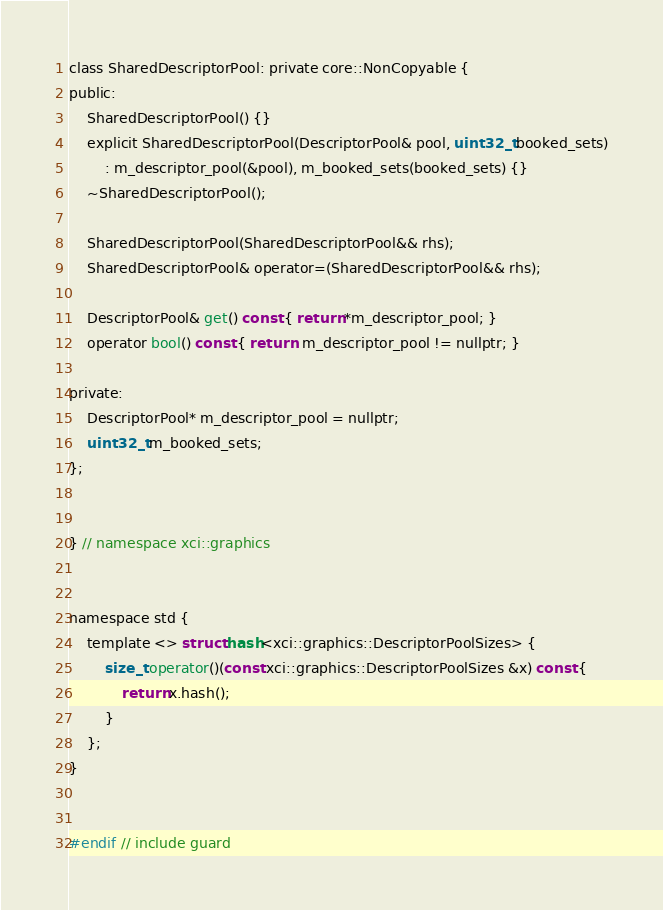Convert code to text. <code><loc_0><loc_0><loc_500><loc_500><_C_>class SharedDescriptorPool: private core::NonCopyable {
public:
    SharedDescriptorPool() {}
    explicit SharedDescriptorPool(DescriptorPool& pool, uint32_t booked_sets)
        : m_descriptor_pool(&pool), m_booked_sets(booked_sets) {}
    ~SharedDescriptorPool();

    SharedDescriptorPool(SharedDescriptorPool&& rhs);
    SharedDescriptorPool& operator=(SharedDescriptorPool&& rhs);

    DescriptorPool& get() const { return *m_descriptor_pool; }
    operator bool() const { return  m_descriptor_pool != nullptr; }

private:
    DescriptorPool* m_descriptor_pool = nullptr;
    uint32_t m_booked_sets;
};


} // namespace xci::graphics


namespace std {
    template <> struct hash<xci::graphics::DescriptorPoolSizes> {
        size_t operator()(const xci::graphics::DescriptorPoolSizes &x) const {
            return x.hash();
        }
    };
}


#endif // include guard
</code> 